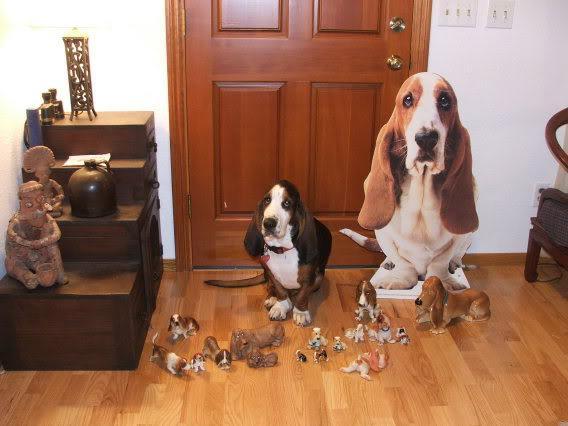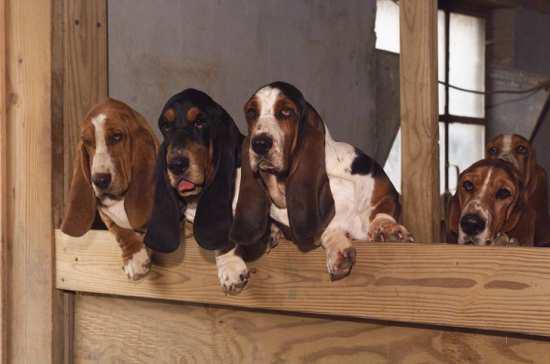The first image is the image on the left, the second image is the image on the right. For the images shown, is this caption "At least one dog is resting on a couch." true? Answer yes or no. No. 